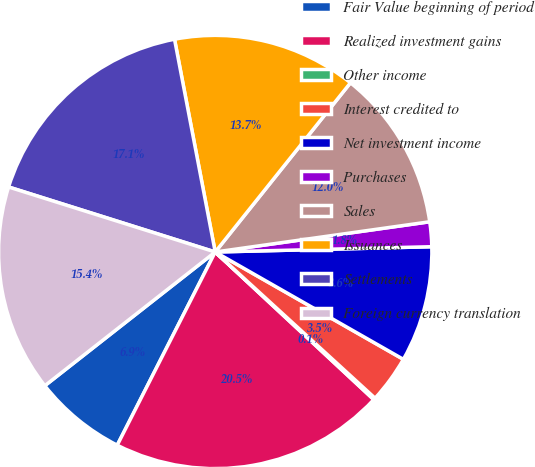Convert chart to OTSL. <chart><loc_0><loc_0><loc_500><loc_500><pie_chart><fcel>Fair Value beginning of period<fcel>Realized investment gains<fcel>Other income<fcel>Interest credited to<fcel>Net investment income<fcel>Purchases<fcel>Sales<fcel>Issuances<fcel>Settlements<fcel>Foreign currency translation<nl><fcel>6.94%<fcel>20.54%<fcel>0.14%<fcel>3.54%<fcel>8.64%<fcel>1.84%<fcel>12.04%<fcel>13.74%<fcel>17.14%<fcel>15.44%<nl></chart> 